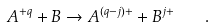<formula> <loc_0><loc_0><loc_500><loc_500>A ^ { + q } + B \to A ^ { ( q - j ) + } + B ^ { j + } \quad .</formula> 